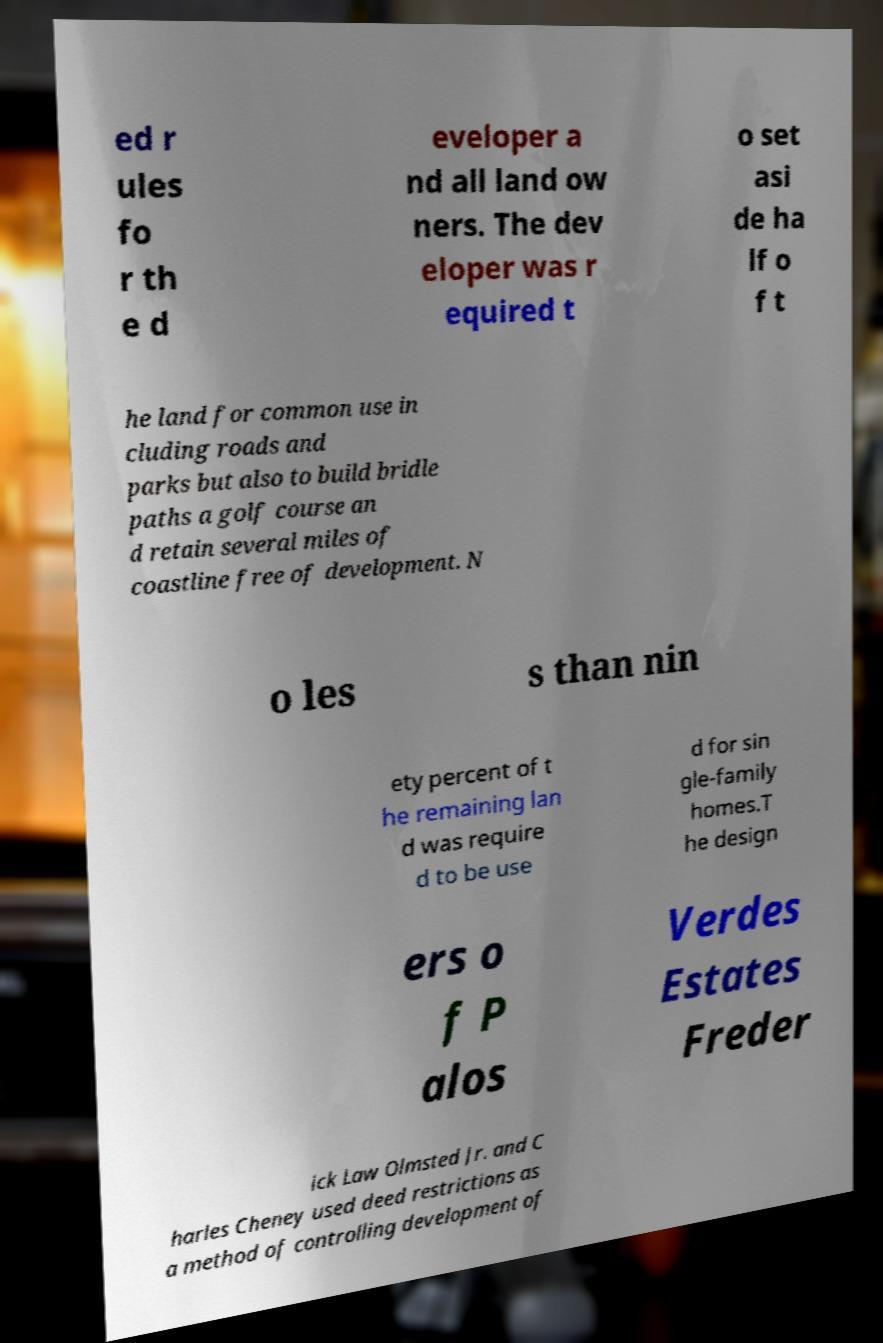Can you accurately transcribe the text from the provided image for me? ed r ules fo r th e d eveloper a nd all land ow ners. The dev eloper was r equired t o set asi de ha lf o f t he land for common use in cluding roads and parks but also to build bridle paths a golf course an d retain several miles of coastline free of development. N o les s than nin ety percent of t he remaining lan d was require d to be use d for sin gle-family homes.T he design ers o f P alos Verdes Estates Freder ick Law Olmsted Jr. and C harles Cheney used deed restrictions as a method of controlling development of 